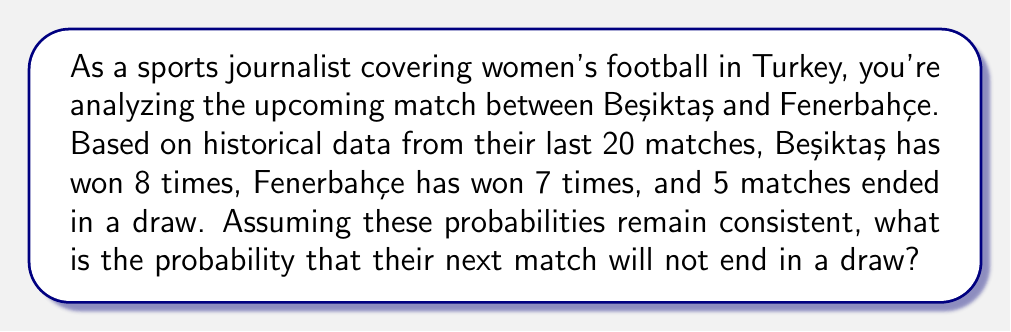Give your solution to this math problem. To solve this problem, we'll use the concept of probability and the given historical data. Let's break it down step-by-step:

1) First, let's calculate the probability of each outcome based on the historical data:

   Total matches: 20
   Beşiktaş wins: 8
   Fenerbahçe wins: 7
   Draws: 5

   $P(\text{Beşiktaş win}) = \frac{8}{20} = 0.4$
   $P(\text{Fenerbahçe win}) = \frac{7}{20} = 0.35$
   $P(\text{Draw}) = \frac{5}{20} = 0.25$

2) The question asks for the probability that the match will not end in a draw. This is equivalent to the probability that either Beşiktaş wins or Fenerbahçe wins.

3) We can calculate this using the complement of the probability of a draw:

   $P(\text{Not a draw}) = 1 - P(\text{Draw})$

4) Substituting the value we calculated for $P(\text{Draw})$:

   $P(\text{Not a draw}) = 1 - 0.25 = 0.75$

5) We can verify this by adding the probabilities of Beşiktaş winning and Fenerbahçe winning:

   $P(\text{Beşiktaş win}) + P(\text{Fenerbahçe win}) = 0.4 + 0.35 = 0.75$

Therefore, the probability that the next match will not end in a draw is 0.75 or 75%.
Answer: 0.75 or 75% 